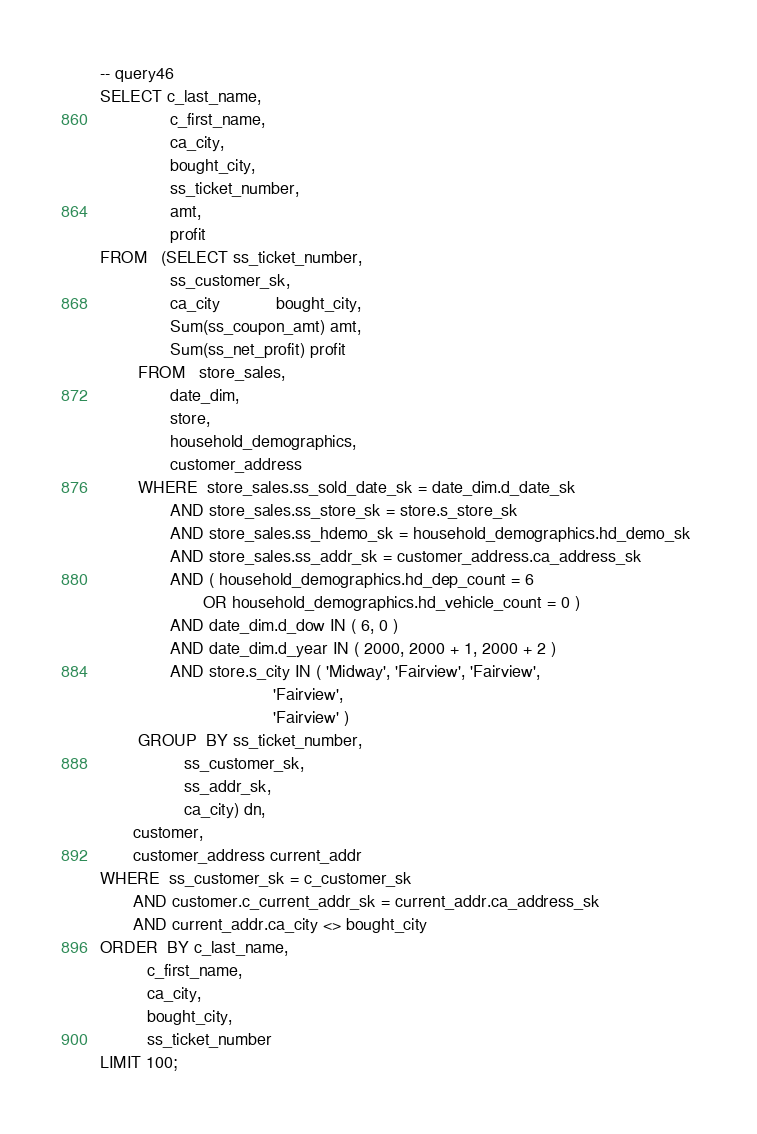Convert code to text. <code><loc_0><loc_0><loc_500><loc_500><_SQL_>-- query46
SELECT c_last_name, 
               c_first_name, 
               ca_city, 
               bought_city, 
               ss_ticket_number, 
               amt, 
               profit 
FROM   (SELECT ss_ticket_number, 
               ss_customer_sk, 
               ca_city            bought_city, 
               Sum(ss_coupon_amt) amt, 
               Sum(ss_net_profit) profit 
        FROM   store_sales, 
               date_dim, 
               store, 
               household_demographics, 
               customer_address 
        WHERE  store_sales.ss_sold_date_sk = date_dim.d_date_sk 
               AND store_sales.ss_store_sk = store.s_store_sk 
               AND store_sales.ss_hdemo_sk = household_demographics.hd_demo_sk 
               AND store_sales.ss_addr_sk = customer_address.ca_address_sk 
               AND ( household_demographics.hd_dep_count = 6 
                      OR household_demographics.hd_vehicle_count = 0 ) 
               AND date_dim.d_dow IN ( 6, 0 ) 
               AND date_dim.d_year IN ( 2000, 2000 + 1, 2000 + 2 ) 
               AND store.s_city IN ( 'Midway', 'Fairview', 'Fairview', 
                                     'Fairview', 
                                     'Fairview' ) 
        GROUP  BY ss_ticket_number, 
                  ss_customer_sk, 
                  ss_addr_sk, 
                  ca_city) dn, 
       customer, 
       customer_address current_addr 
WHERE  ss_customer_sk = c_customer_sk 
       AND customer.c_current_addr_sk = current_addr.ca_address_sk 
       AND current_addr.ca_city <> bought_city 
ORDER  BY c_last_name, 
          c_first_name, 
          ca_city, 
          bought_city, 
          ss_ticket_number
LIMIT 100; 
</code> 